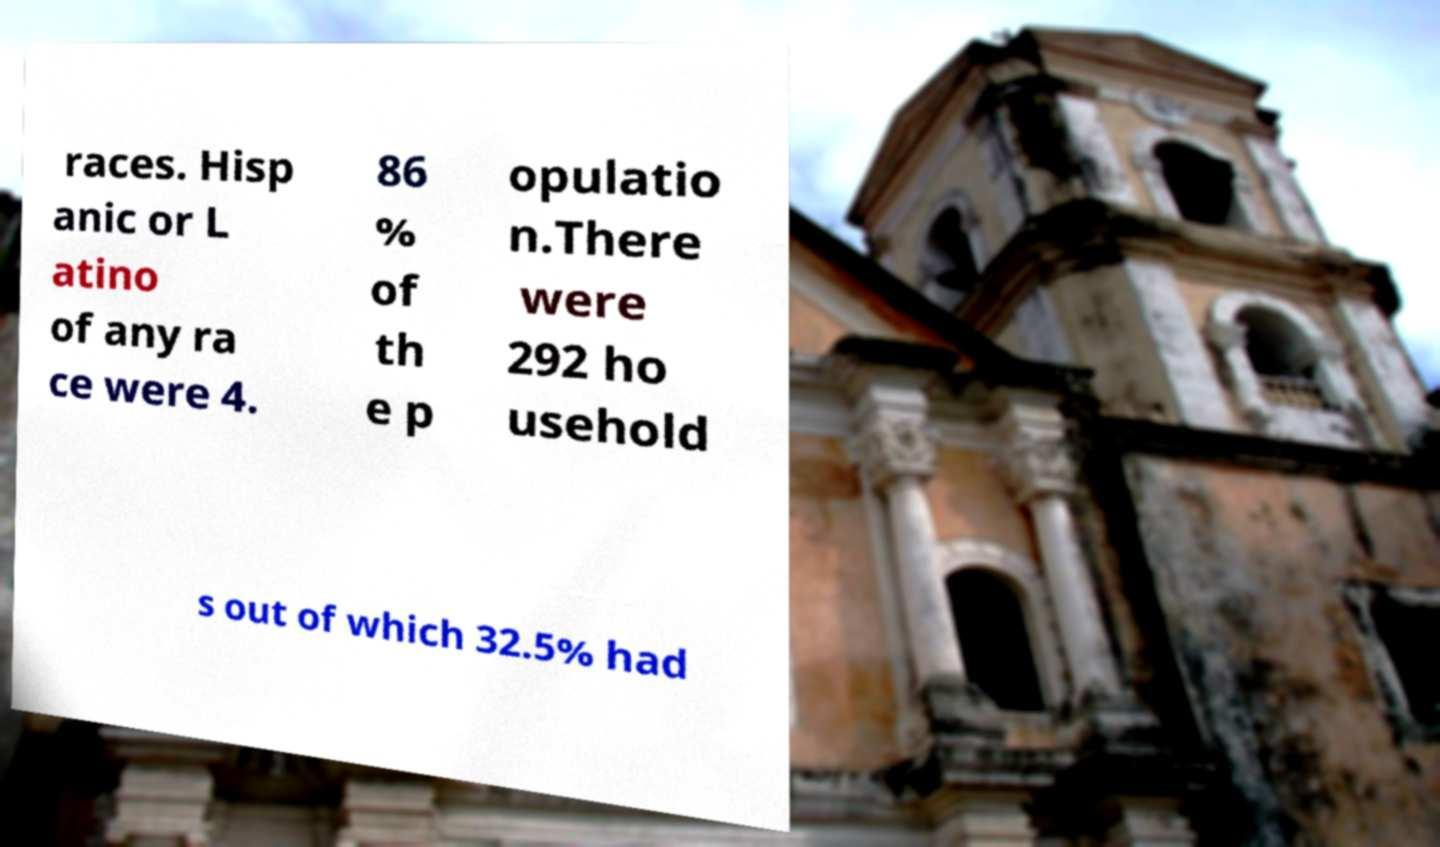What messages or text are displayed in this image? I need them in a readable, typed format. races. Hisp anic or L atino of any ra ce were 4. 86 % of th e p opulatio n.There were 292 ho usehold s out of which 32.5% had 